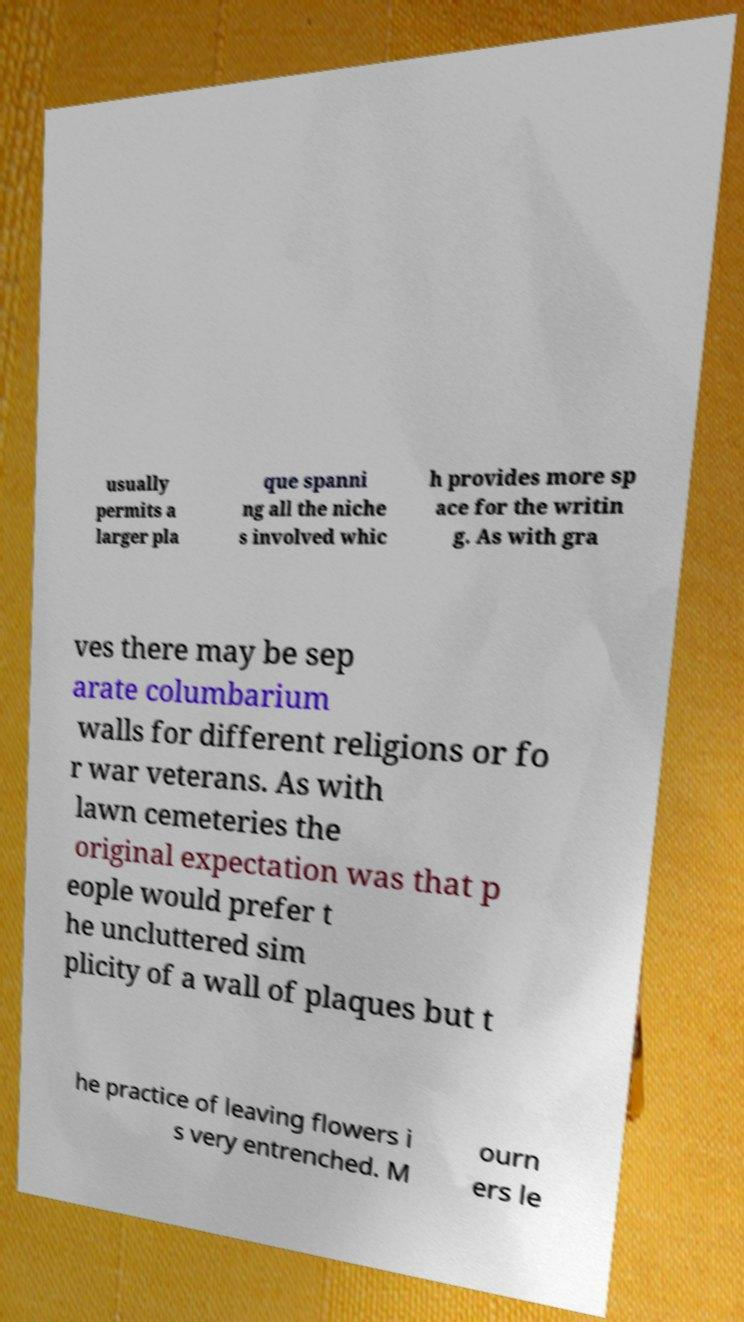I need the written content from this picture converted into text. Can you do that? usually permits a larger pla que spanni ng all the niche s involved whic h provides more sp ace for the writin g. As with gra ves there may be sep arate columbarium walls for different religions or fo r war veterans. As with lawn cemeteries the original expectation was that p eople would prefer t he uncluttered sim plicity of a wall of plaques but t he practice of leaving flowers i s very entrenched. M ourn ers le 